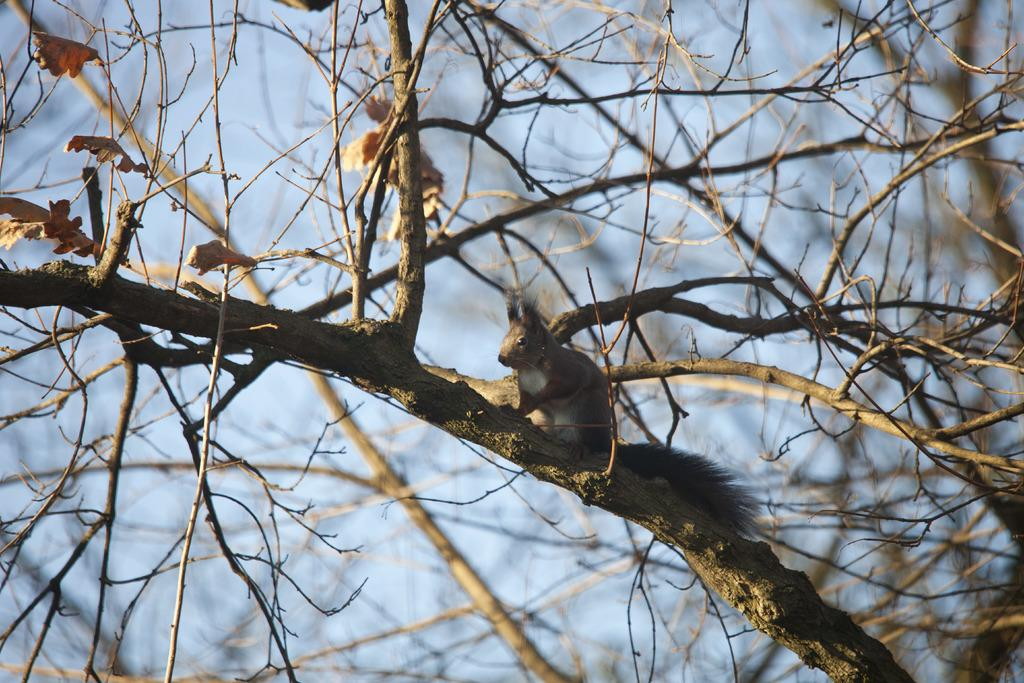What type of vegetation can be seen in the image? There are stems of a tree in the image. Is there any wildlife present in the image? Yes, there is a squirrel on a stem in the image. What can be seen in the background of the image? The sky is visible in the background of the image. What type of popcorn is being served on the ground in the image? There is no popcorn or ground present in the image; it features stems of a tree and a squirrel. What type of creature is shown interacting with the tree in the image? There is no creature shown interacting with the tree in the image; only the squirrel is present. 